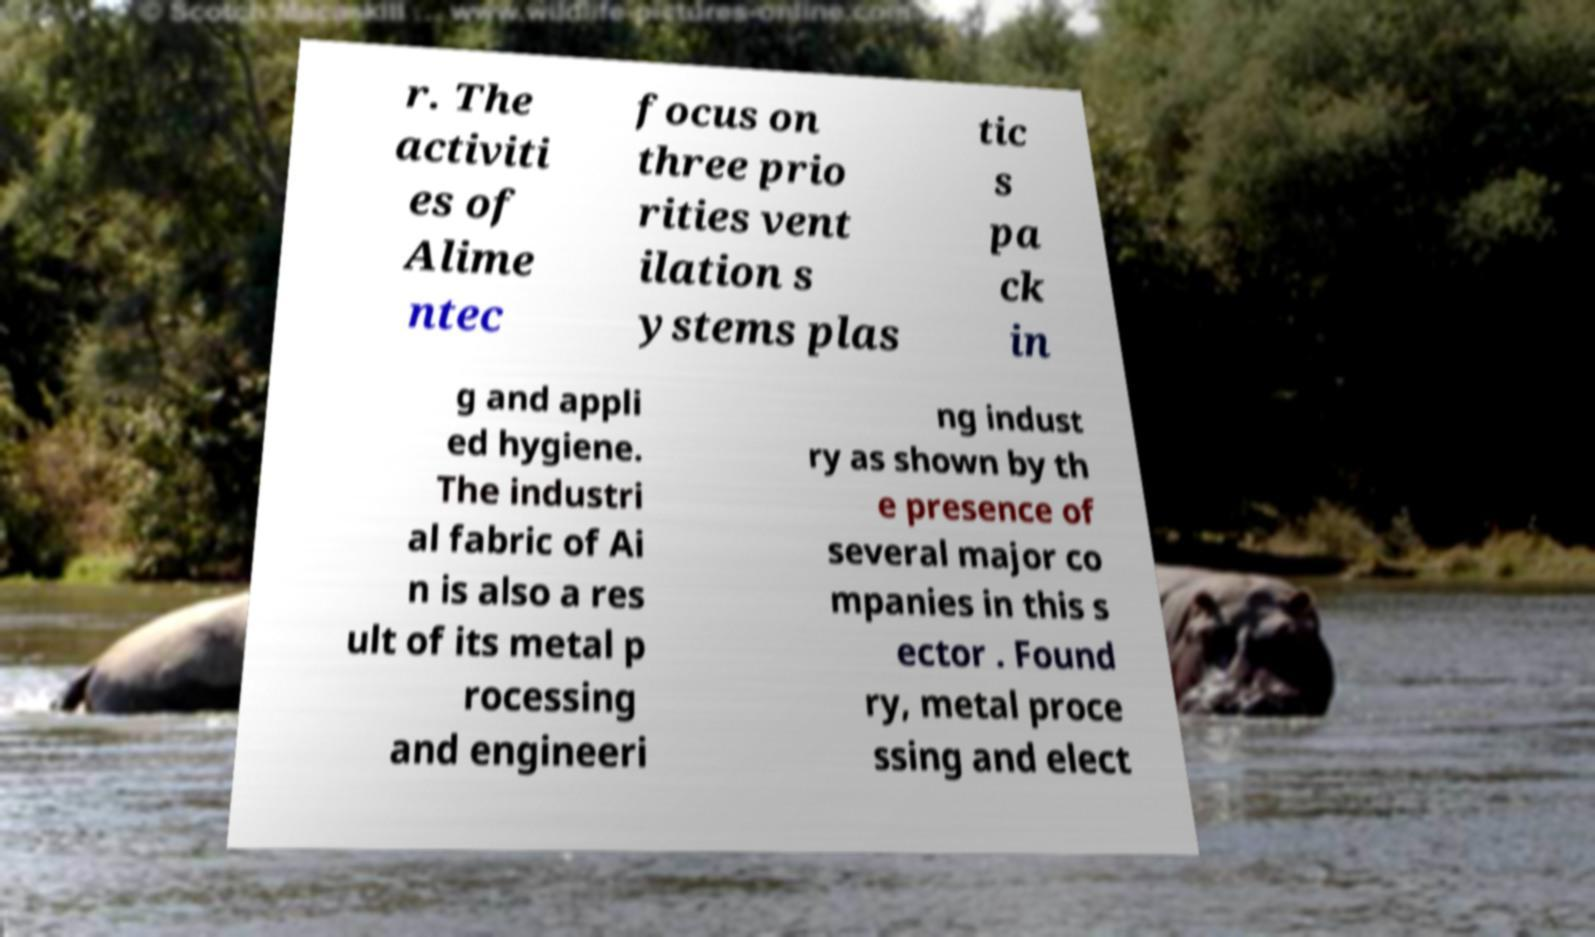Could you assist in decoding the text presented in this image and type it out clearly? r. The activiti es of Alime ntec focus on three prio rities vent ilation s ystems plas tic s pa ck in g and appli ed hygiene. The industri al fabric of Ai n is also a res ult of its metal p rocessing and engineeri ng indust ry as shown by th e presence of several major co mpanies in this s ector . Found ry, metal proce ssing and elect 